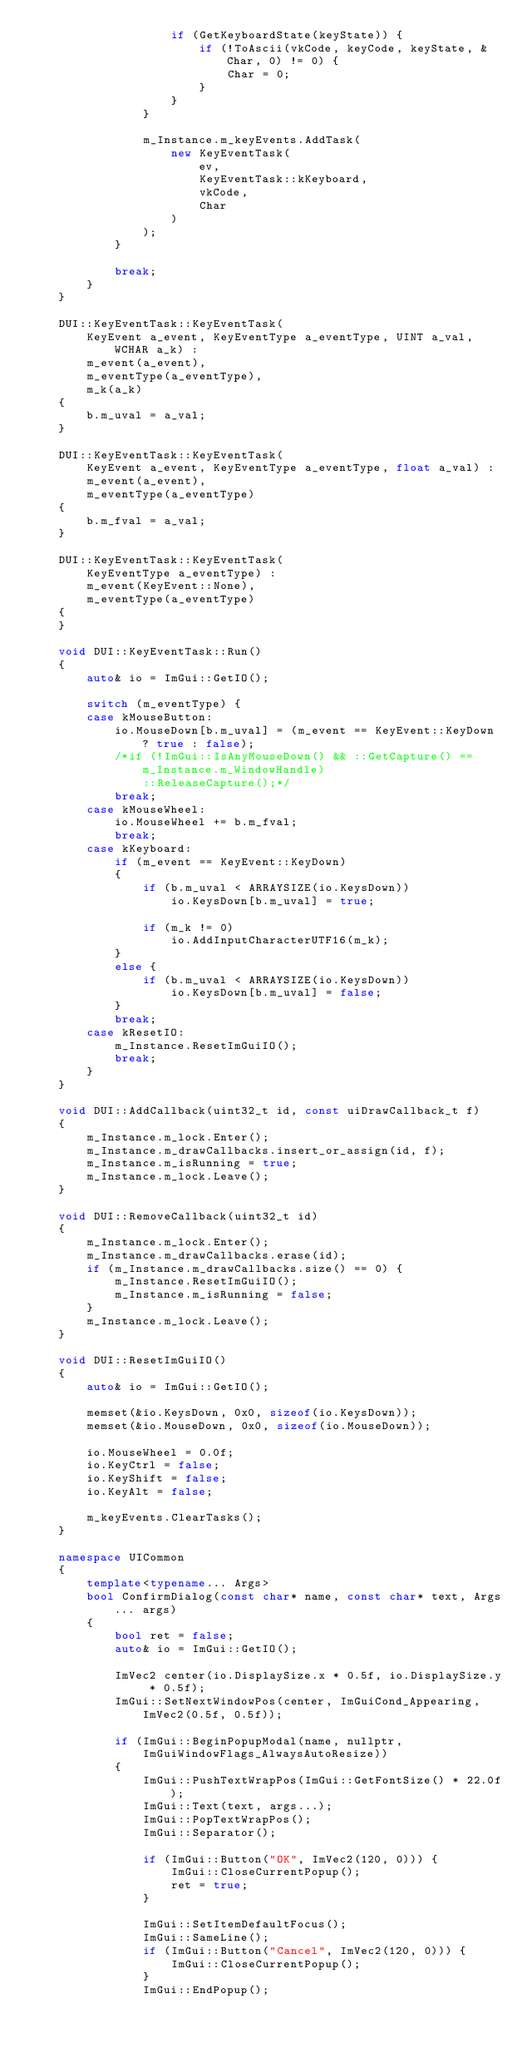Convert code to text. <code><loc_0><loc_0><loc_500><loc_500><_C++_>                    if (GetKeyboardState(keyState)) {
                        if (!ToAscii(vkCode, keyCode, keyState, &Char, 0) != 0) {
                            Char = 0;
                        }
                    }
                }

                m_Instance.m_keyEvents.AddTask(
                    new KeyEventTask(
                        ev,
                        KeyEventTask::kKeyboard,
                        vkCode,
                        Char
                    )
                );
            }

            break;
        }
    }

    DUI::KeyEventTask::KeyEventTask(
        KeyEvent a_event, KeyEventType a_eventType, UINT a_val, WCHAR a_k) :
        m_event(a_event),
        m_eventType(a_eventType),
        m_k(a_k)
    {
        b.m_uval = a_val;
    }

    DUI::KeyEventTask::KeyEventTask(
        KeyEvent a_event, KeyEventType a_eventType, float a_val) :
        m_event(a_event),
        m_eventType(a_eventType)
    {
        b.m_fval = a_val;
    }

    DUI::KeyEventTask::KeyEventTask(
        KeyEventType a_eventType) :
        m_event(KeyEvent::None),
        m_eventType(a_eventType)
    {
    }

    void DUI::KeyEventTask::Run()
    {
        auto& io = ImGui::GetIO();

        switch (m_eventType) {
        case kMouseButton:
            io.MouseDown[b.m_uval] = (m_event == KeyEvent::KeyDown ? true : false);
            /*if (!ImGui::IsAnyMouseDown() && ::GetCapture() == m_Instance.m_WindowHandle)
                ::ReleaseCapture();*/
            break;
        case kMouseWheel:
            io.MouseWheel += b.m_fval;
            break;
        case kKeyboard:
            if (m_event == KeyEvent::KeyDown)
            {
                if (b.m_uval < ARRAYSIZE(io.KeysDown))
                    io.KeysDown[b.m_uval] = true;

                if (m_k != 0)
                    io.AddInputCharacterUTF16(m_k);
            }
            else {
                if (b.m_uval < ARRAYSIZE(io.KeysDown))
                    io.KeysDown[b.m_uval] = false;
            }
            break;
        case kResetIO:
            m_Instance.ResetImGuiIO();
            break;
        }
    }

    void DUI::AddCallback(uint32_t id, const uiDrawCallback_t f)
    {
        m_Instance.m_lock.Enter();
        m_Instance.m_drawCallbacks.insert_or_assign(id, f);
        m_Instance.m_isRunning = true;
        m_Instance.m_lock.Leave();
    }

    void DUI::RemoveCallback(uint32_t id)
    {
        m_Instance.m_lock.Enter();
        m_Instance.m_drawCallbacks.erase(id);
        if (m_Instance.m_drawCallbacks.size() == 0) {
            m_Instance.ResetImGuiIO();
            m_Instance.m_isRunning = false;
        }
        m_Instance.m_lock.Leave();
    }

    void DUI::ResetImGuiIO()
    {
        auto& io = ImGui::GetIO();

        memset(&io.KeysDown, 0x0, sizeof(io.KeysDown));
        memset(&io.MouseDown, 0x0, sizeof(io.MouseDown));

        io.MouseWheel = 0.0f;
        io.KeyCtrl = false;
        io.KeyShift = false;
        io.KeyAlt = false;

        m_keyEvents.ClearTasks();
    }

    namespace UICommon
    {
        template<typename... Args>
        bool ConfirmDialog(const char* name, const char* text, Args... args)
        {
            bool ret = false;
            auto& io = ImGui::GetIO();

            ImVec2 center(io.DisplaySize.x * 0.5f, io.DisplaySize.y * 0.5f);
            ImGui::SetNextWindowPos(center, ImGuiCond_Appearing, ImVec2(0.5f, 0.5f));

            if (ImGui::BeginPopupModal(name, nullptr, ImGuiWindowFlags_AlwaysAutoResize))
            {
                ImGui::PushTextWrapPos(ImGui::GetFontSize() * 22.0f);
                ImGui::Text(text, args...);
                ImGui::PopTextWrapPos();
                ImGui::Separator();

                if (ImGui::Button("OK", ImVec2(120, 0))) {
                    ImGui::CloseCurrentPopup();
                    ret = true;
                }

                ImGui::SetItemDefaultFocus();
                ImGui::SameLine();
                if (ImGui::Button("Cancel", ImVec2(120, 0))) {
                    ImGui::CloseCurrentPopup();
                }
                ImGui::EndPopup();</code> 